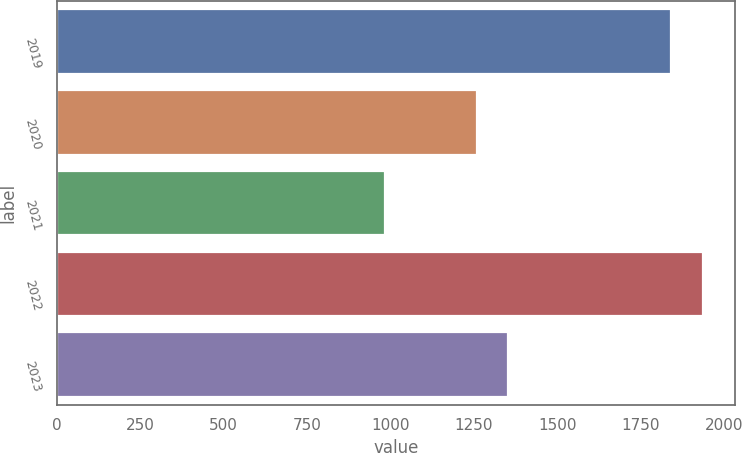<chart> <loc_0><loc_0><loc_500><loc_500><bar_chart><fcel>2019<fcel>2020<fcel>2021<fcel>2022<fcel>2023<nl><fcel>1841<fcel>1259<fcel>983<fcel>1936.2<fcel>1354.2<nl></chart> 